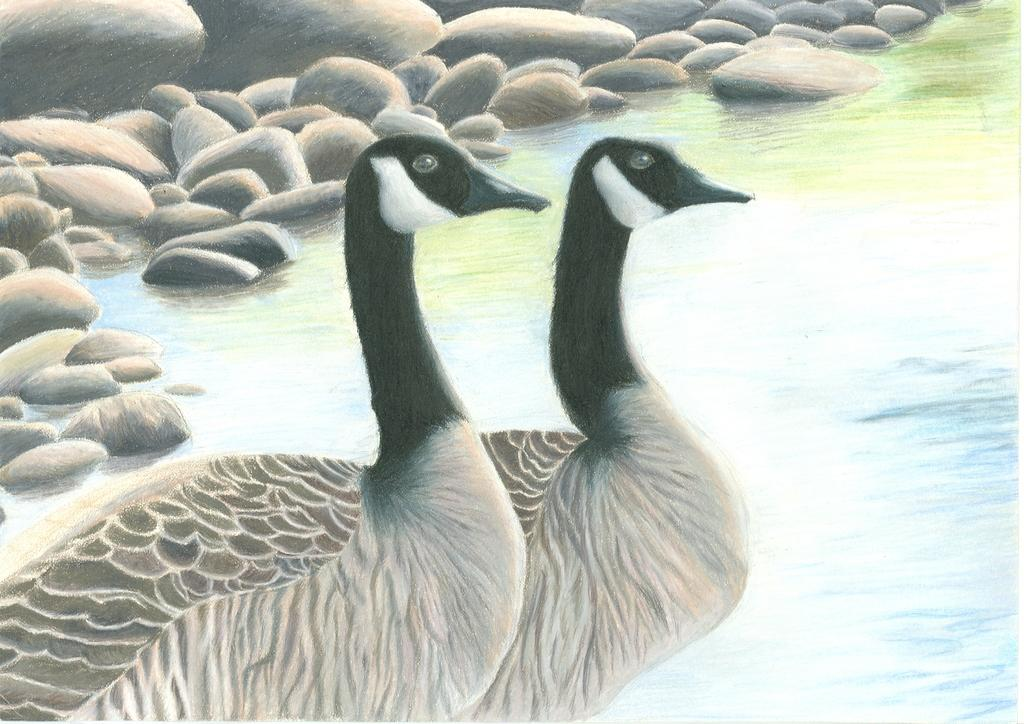How many birds are present in the image? There are two birds in the image. What colors can be seen on the birds? The birds have black, brown, and white coloring. What can be seen in the background of the image? There are stones visible in the background of the image. What type of writer is sitting on the kettle in the image? There is no writer or kettle present in the image; it features two birds with black, brown, and white coloring, and stones in the background. 